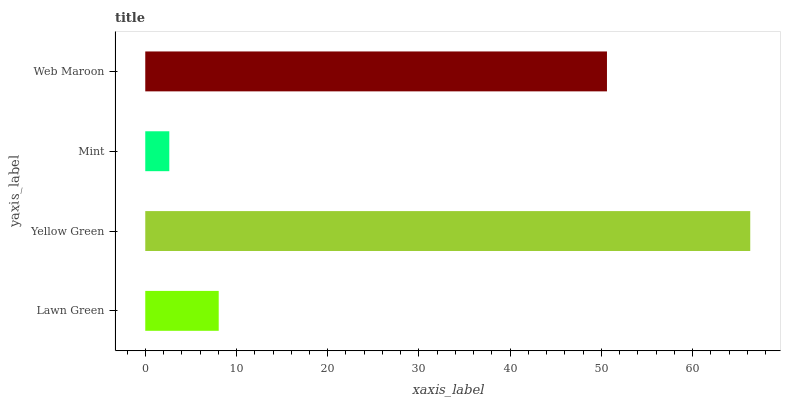Is Mint the minimum?
Answer yes or no. Yes. Is Yellow Green the maximum?
Answer yes or no. Yes. Is Yellow Green the minimum?
Answer yes or no. No. Is Mint the maximum?
Answer yes or no. No. Is Yellow Green greater than Mint?
Answer yes or no. Yes. Is Mint less than Yellow Green?
Answer yes or no. Yes. Is Mint greater than Yellow Green?
Answer yes or no. No. Is Yellow Green less than Mint?
Answer yes or no. No. Is Web Maroon the high median?
Answer yes or no. Yes. Is Lawn Green the low median?
Answer yes or no. Yes. Is Lawn Green the high median?
Answer yes or no. No. Is Web Maroon the low median?
Answer yes or no. No. 